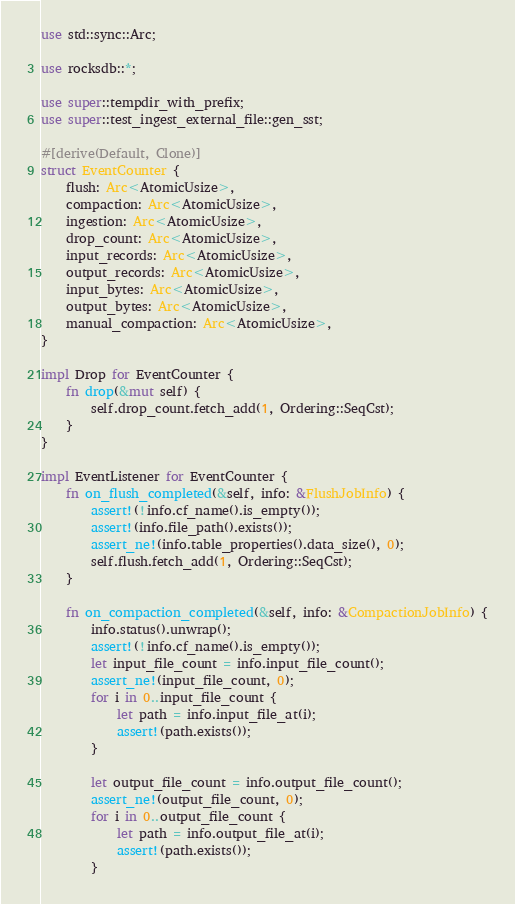<code> <loc_0><loc_0><loc_500><loc_500><_Rust_>use std::sync::Arc;

use rocksdb::*;

use super::tempdir_with_prefix;
use super::test_ingest_external_file::gen_sst;

#[derive(Default, Clone)]
struct EventCounter {
    flush: Arc<AtomicUsize>,
    compaction: Arc<AtomicUsize>,
    ingestion: Arc<AtomicUsize>,
    drop_count: Arc<AtomicUsize>,
    input_records: Arc<AtomicUsize>,
    output_records: Arc<AtomicUsize>,
    input_bytes: Arc<AtomicUsize>,
    output_bytes: Arc<AtomicUsize>,
    manual_compaction: Arc<AtomicUsize>,
}

impl Drop for EventCounter {
    fn drop(&mut self) {
        self.drop_count.fetch_add(1, Ordering::SeqCst);
    }
}

impl EventListener for EventCounter {
    fn on_flush_completed(&self, info: &FlushJobInfo) {
        assert!(!info.cf_name().is_empty());
        assert!(info.file_path().exists());
        assert_ne!(info.table_properties().data_size(), 0);
        self.flush.fetch_add(1, Ordering::SeqCst);
    }

    fn on_compaction_completed(&self, info: &CompactionJobInfo) {
        info.status().unwrap();
        assert!(!info.cf_name().is_empty());
        let input_file_count = info.input_file_count();
        assert_ne!(input_file_count, 0);
        for i in 0..input_file_count {
            let path = info.input_file_at(i);
            assert!(path.exists());
        }

        let output_file_count = info.output_file_count();
        assert_ne!(output_file_count, 0);
        for i in 0..output_file_count {
            let path = info.output_file_at(i);
            assert!(path.exists());
        }
</code> 